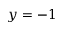Convert formula to latex. <formula><loc_0><loc_0><loc_500><loc_500>y = - 1</formula> 